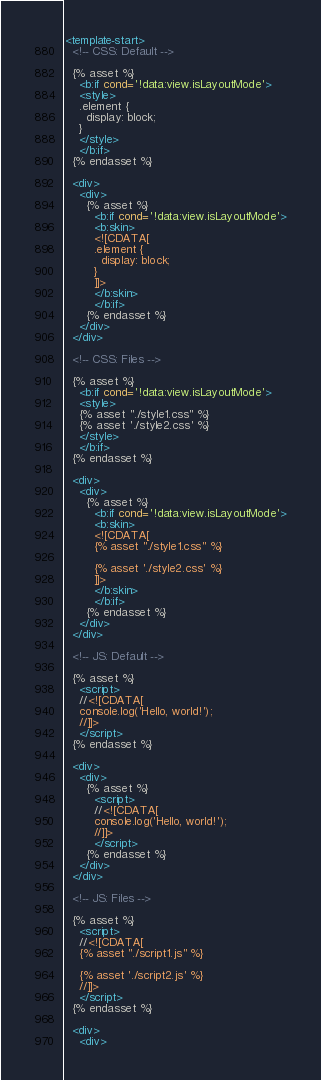Convert code to text. <code><loc_0><loc_0><loc_500><loc_500><_XML_><template-start>
  <!-- CSS: Default -->

  {% asset %}
    <b:if cond='!data:view.isLayoutMode'>
    <style>
    .element {
      display: block;
    }
    </style>
    </b:if>
  {% endasset %}

  <div>
    <div>
      {% asset %}
        <b:if cond='!data:view.isLayoutMode'>
        <b:skin>
        <![CDATA[
        .element {
          display: block;
        }
        ]]>
        </b:skin>
        </b:if>
      {% endasset %}
    </div>
  </div>

  <!-- CSS: Files -->

  {% asset %}
    <b:if cond='!data:view.isLayoutMode'>
    <style>
    {% asset "./style1.css" %}
    {% asset './style2.css' %}
    </style>
    </b:if>
  {% endasset %}

  <div>
    <div>
      {% asset %}
        <b:if cond='!data:view.isLayoutMode'>
        <b:skin>
        <![CDATA[
        {% asset "./style1.css" %}

        {% asset './style2.css' %}
        ]]>
        </b:skin>
        </b:if>
      {% endasset %}
    </div>
  </div>

  <!-- JS: Default -->

  {% asset %}
    <script>
    //<![CDATA[
    console.log('Hello, world!');
    //]]>
    </script>
  {% endasset %}

  <div>
    <div>
      {% asset %}
        <script>
        //<![CDATA[
        console.log('Hello, world!');
        //]]>
        </script>
      {% endasset %}
    </div>
  </div>

  <!-- JS: Files -->

  {% asset %}
    <script>
    //<![CDATA[
    {% asset "./script1.js" %}

    {% asset './script2.js' %}
    //]]>
    </script>
  {% endasset %}

  <div>
    <div></code> 